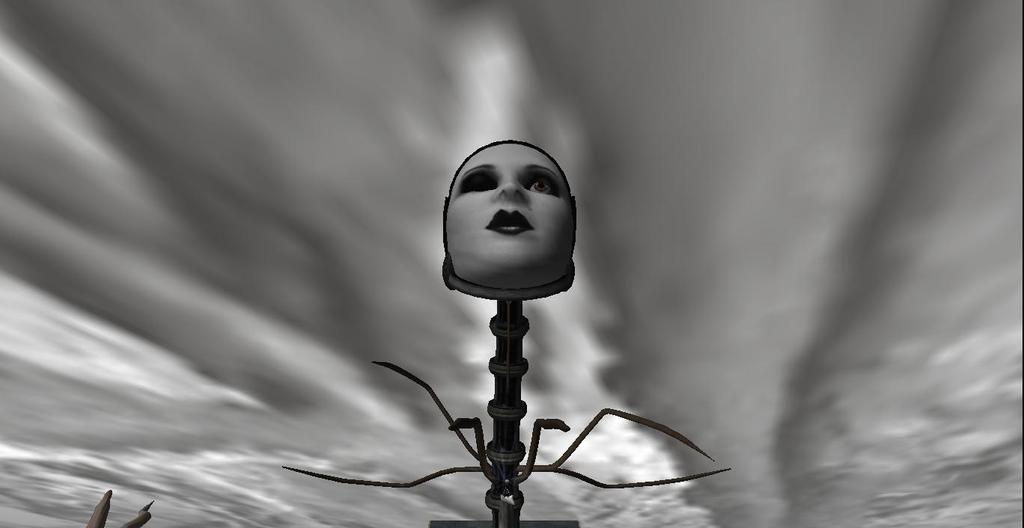What can be seen in the image? There is an object in the image. What is the condition of the sky in the background? The sky in the background is cloudy. What type of vase can be seen on the sidewalk in the image? There is no vase or sidewalk present in the image. How many times does the object in the image twist? The object in the image does not twist, as there is no indication of this in the provided facts. 